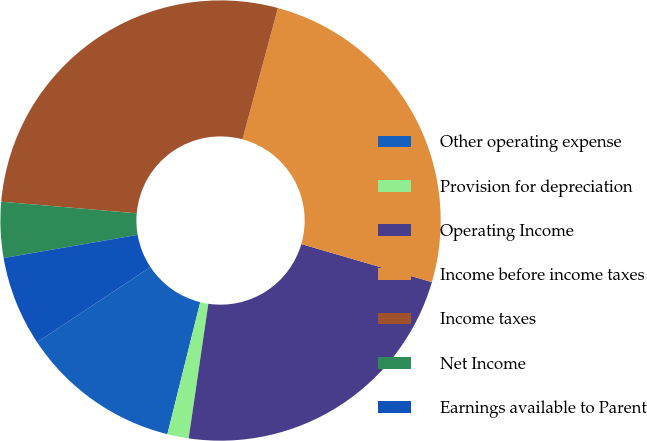Convert chart. <chart><loc_0><loc_0><loc_500><loc_500><pie_chart><fcel>Other operating expense<fcel>Provision for depreciation<fcel>Operating Income<fcel>Income before income taxes<fcel>Income taxes<fcel>Net Income<fcel>Earnings available to Parent<nl><fcel>11.79%<fcel>1.57%<fcel>22.8%<fcel>25.31%<fcel>27.83%<fcel>4.09%<fcel>6.6%<nl></chart> 